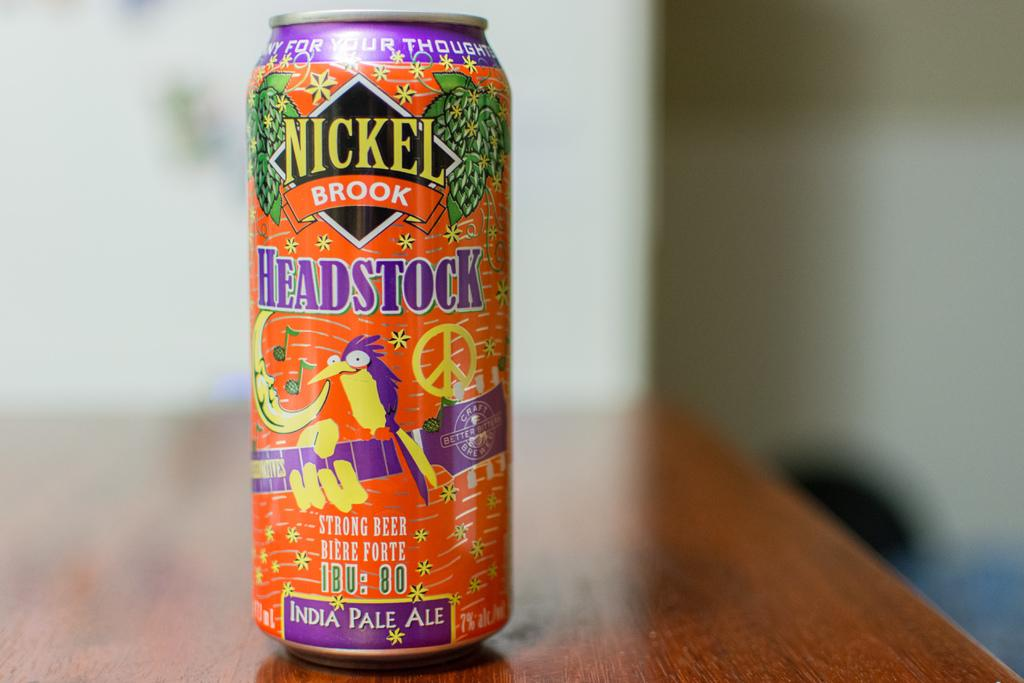<image>
Render a clear and concise summary of the photo. The orange and purple can of India Pale Ale has an illustration of a bird on a guitar. 